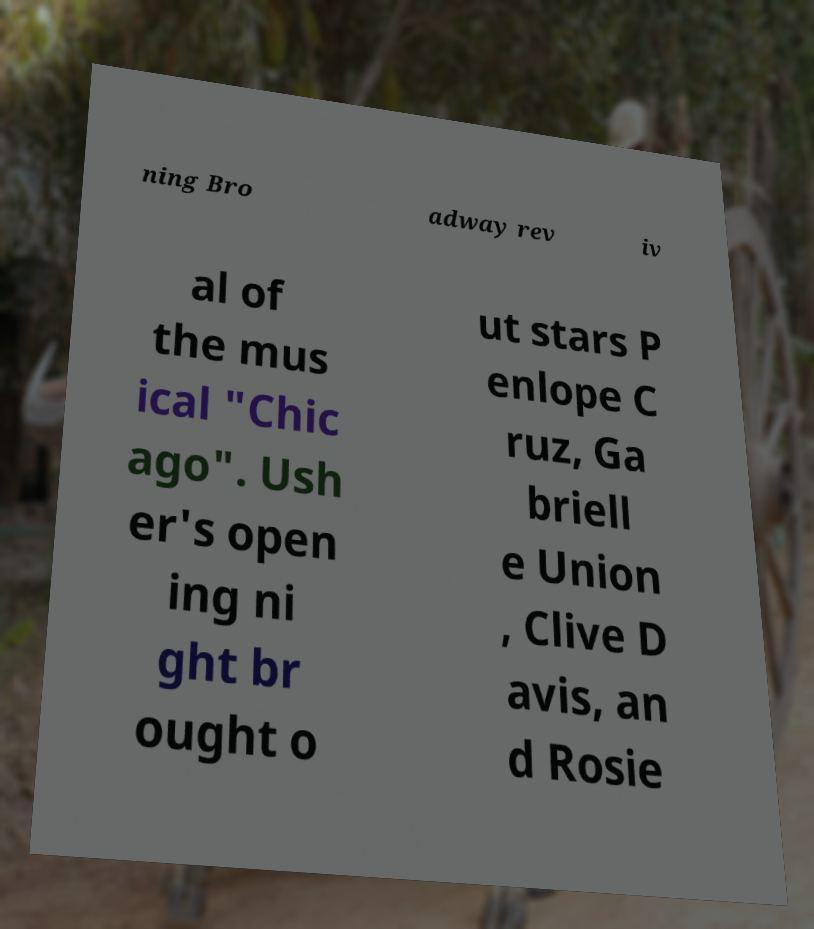I need the written content from this picture converted into text. Can you do that? ning Bro adway rev iv al of the mus ical "Chic ago". Ush er's open ing ni ght br ought o ut stars P enlope C ruz, Ga briell e Union , Clive D avis, an d Rosie 